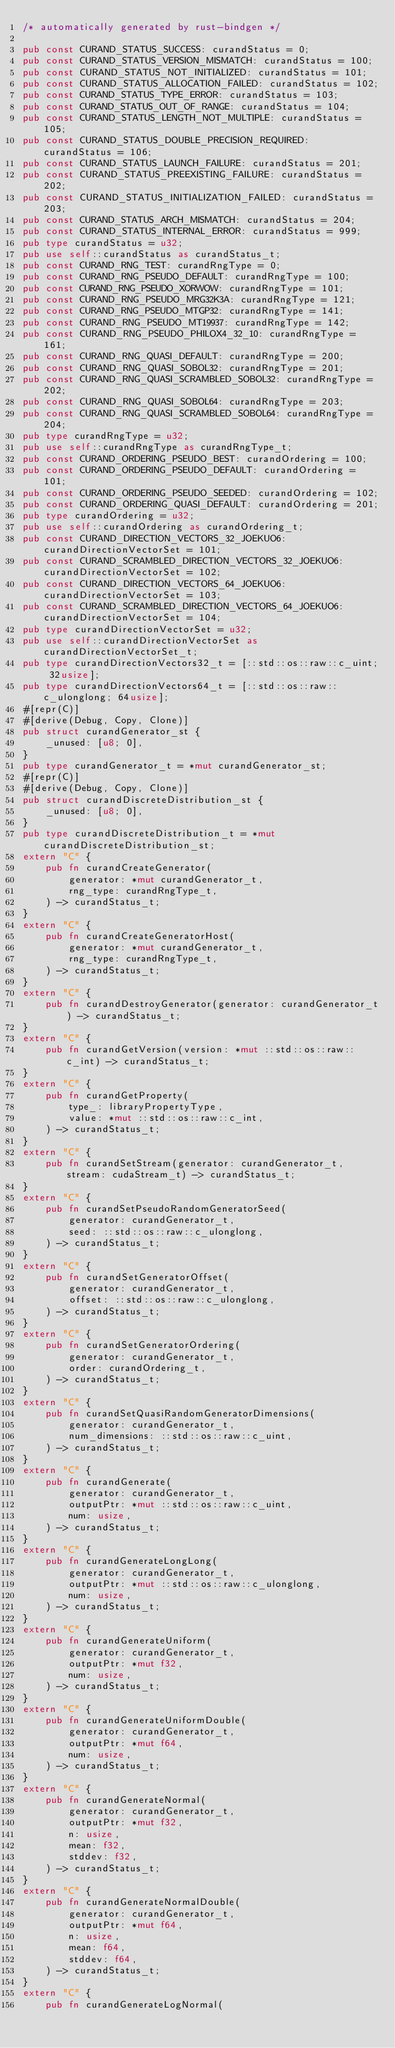Convert code to text. <code><loc_0><loc_0><loc_500><loc_500><_Rust_>/* automatically generated by rust-bindgen */

pub const CURAND_STATUS_SUCCESS: curandStatus = 0;
pub const CURAND_STATUS_VERSION_MISMATCH: curandStatus = 100;
pub const CURAND_STATUS_NOT_INITIALIZED: curandStatus = 101;
pub const CURAND_STATUS_ALLOCATION_FAILED: curandStatus = 102;
pub const CURAND_STATUS_TYPE_ERROR: curandStatus = 103;
pub const CURAND_STATUS_OUT_OF_RANGE: curandStatus = 104;
pub const CURAND_STATUS_LENGTH_NOT_MULTIPLE: curandStatus = 105;
pub const CURAND_STATUS_DOUBLE_PRECISION_REQUIRED: curandStatus = 106;
pub const CURAND_STATUS_LAUNCH_FAILURE: curandStatus = 201;
pub const CURAND_STATUS_PREEXISTING_FAILURE: curandStatus = 202;
pub const CURAND_STATUS_INITIALIZATION_FAILED: curandStatus = 203;
pub const CURAND_STATUS_ARCH_MISMATCH: curandStatus = 204;
pub const CURAND_STATUS_INTERNAL_ERROR: curandStatus = 999;
pub type curandStatus = u32;
pub use self::curandStatus as curandStatus_t;
pub const CURAND_RNG_TEST: curandRngType = 0;
pub const CURAND_RNG_PSEUDO_DEFAULT: curandRngType = 100;
pub const CURAND_RNG_PSEUDO_XORWOW: curandRngType = 101;
pub const CURAND_RNG_PSEUDO_MRG32K3A: curandRngType = 121;
pub const CURAND_RNG_PSEUDO_MTGP32: curandRngType = 141;
pub const CURAND_RNG_PSEUDO_MT19937: curandRngType = 142;
pub const CURAND_RNG_PSEUDO_PHILOX4_32_10: curandRngType = 161;
pub const CURAND_RNG_QUASI_DEFAULT: curandRngType = 200;
pub const CURAND_RNG_QUASI_SOBOL32: curandRngType = 201;
pub const CURAND_RNG_QUASI_SCRAMBLED_SOBOL32: curandRngType = 202;
pub const CURAND_RNG_QUASI_SOBOL64: curandRngType = 203;
pub const CURAND_RNG_QUASI_SCRAMBLED_SOBOL64: curandRngType = 204;
pub type curandRngType = u32;
pub use self::curandRngType as curandRngType_t;
pub const CURAND_ORDERING_PSEUDO_BEST: curandOrdering = 100;
pub const CURAND_ORDERING_PSEUDO_DEFAULT: curandOrdering = 101;
pub const CURAND_ORDERING_PSEUDO_SEEDED: curandOrdering = 102;
pub const CURAND_ORDERING_QUASI_DEFAULT: curandOrdering = 201;
pub type curandOrdering = u32;
pub use self::curandOrdering as curandOrdering_t;
pub const CURAND_DIRECTION_VECTORS_32_JOEKUO6: curandDirectionVectorSet = 101;
pub const CURAND_SCRAMBLED_DIRECTION_VECTORS_32_JOEKUO6: curandDirectionVectorSet = 102;
pub const CURAND_DIRECTION_VECTORS_64_JOEKUO6: curandDirectionVectorSet = 103;
pub const CURAND_SCRAMBLED_DIRECTION_VECTORS_64_JOEKUO6: curandDirectionVectorSet = 104;
pub type curandDirectionVectorSet = u32;
pub use self::curandDirectionVectorSet as curandDirectionVectorSet_t;
pub type curandDirectionVectors32_t = [::std::os::raw::c_uint; 32usize];
pub type curandDirectionVectors64_t = [::std::os::raw::c_ulonglong; 64usize];
#[repr(C)]
#[derive(Debug, Copy, Clone)]
pub struct curandGenerator_st {
    _unused: [u8; 0],
}
pub type curandGenerator_t = *mut curandGenerator_st;
#[repr(C)]
#[derive(Debug, Copy, Clone)]
pub struct curandDiscreteDistribution_st {
    _unused: [u8; 0],
}
pub type curandDiscreteDistribution_t = *mut curandDiscreteDistribution_st;
extern "C" {
    pub fn curandCreateGenerator(
        generator: *mut curandGenerator_t,
        rng_type: curandRngType_t,
    ) -> curandStatus_t;
}
extern "C" {
    pub fn curandCreateGeneratorHost(
        generator: *mut curandGenerator_t,
        rng_type: curandRngType_t,
    ) -> curandStatus_t;
}
extern "C" {
    pub fn curandDestroyGenerator(generator: curandGenerator_t) -> curandStatus_t;
}
extern "C" {
    pub fn curandGetVersion(version: *mut ::std::os::raw::c_int) -> curandStatus_t;
}
extern "C" {
    pub fn curandGetProperty(
        type_: libraryPropertyType,
        value: *mut ::std::os::raw::c_int,
    ) -> curandStatus_t;
}
extern "C" {
    pub fn curandSetStream(generator: curandGenerator_t, stream: cudaStream_t) -> curandStatus_t;
}
extern "C" {
    pub fn curandSetPseudoRandomGeneratorSeed(
        generator: curandGenerator_t,
        seed: ::std::os::raw::c_ulonglong,
    ) -> curandStatus_t;
}
extern "C" {
    pub fn curandSetGeneratorOffset(
        generator: curandGenerator_t,
        offset: ::std::os::raw::c_ulonglong,
    ) -> curandStatus_t;
}
extern "C" {
    pub fn curandSetGeneratorOrdering(
        generator: curandGenerator_t,
        order: curandOrdering_t,
    ) -> curandStatus_t;
}
extern "C" {
    pub fn curandSetQuasiRandomGeneratorDimensions(
        generator: curandGenerator_t,
        num_dimensions: ::std::os::raw::c_uint,
    ) -> curandStatus_t;
}
extern "C" {
    pub fn curandGenerate(
        generator: curandGenerator_t,
        outputPtr: *mut ::std::os::raw::c_uint,
        num: usize,
    ) -> curandStatus_t;
}
extern "C" {
    pub fn curandGenerateLongLong(
        generator: curandGenerator_t,
        outputPtr: *mut ::std::os::raw::c_ulonglong,
        num: usize,
    ) -> curandStatus_t;
}
extern "C" {
    pub fn curandGenerateUniform(
        generator: curandGenerator_t,
        outputPtr: *mut f32,
        num: usize,
    ) -> curandStatus_t;
}
extern "C" {
    pub fn curandGenerateUniformDouble(
        generator: curandGenerator_t,
        outputPtr: *mut f64,
        num: usize,
    ) -> curandStatus_t;
}
extern "C" {
    pub fn curandGenerateNormal(
        generator: curandGenerator_t,
        outputPtr: *mut f32,
        n: usize,
        mean: f32,
        stddev: f32,
    ) -> curandStatus_t;
}
extern "C" {
    pub fn curandGenerateNormalDouble(
        generator: curandGenerator_t,
        outputPtr: *mut f64,
        n: usize,
        mean: f64,
        stddev: f64,
    ) -> curandStatus_t;
}
extern "C" {
    pub fn curandGenerateLogNormal(</code> 